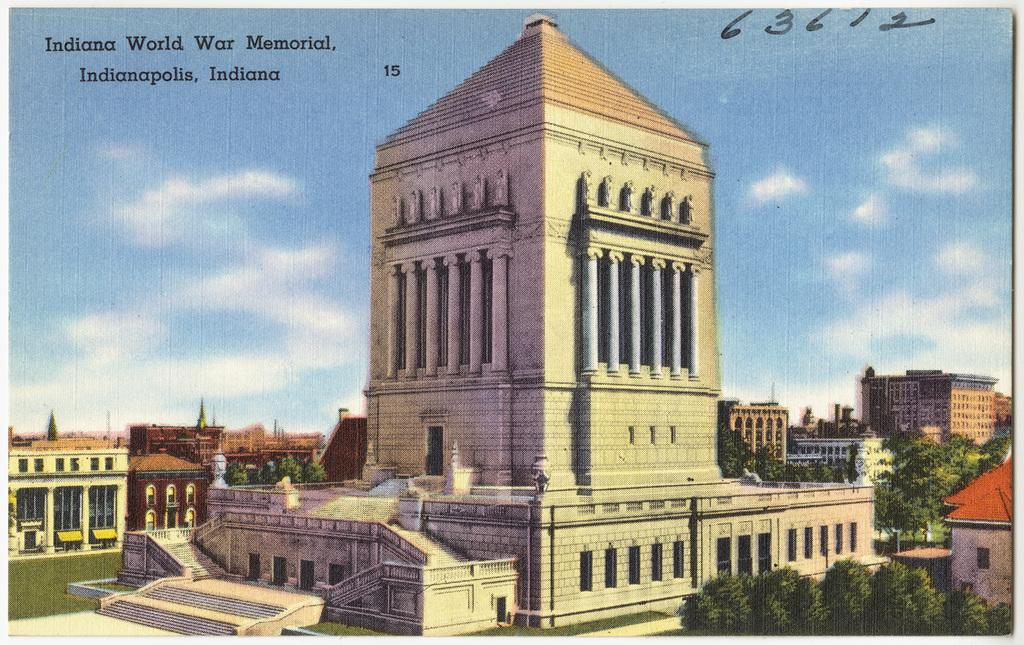<image>
Render a clear and concise summary of the photo. A drawing of a war memorial in Indian. 